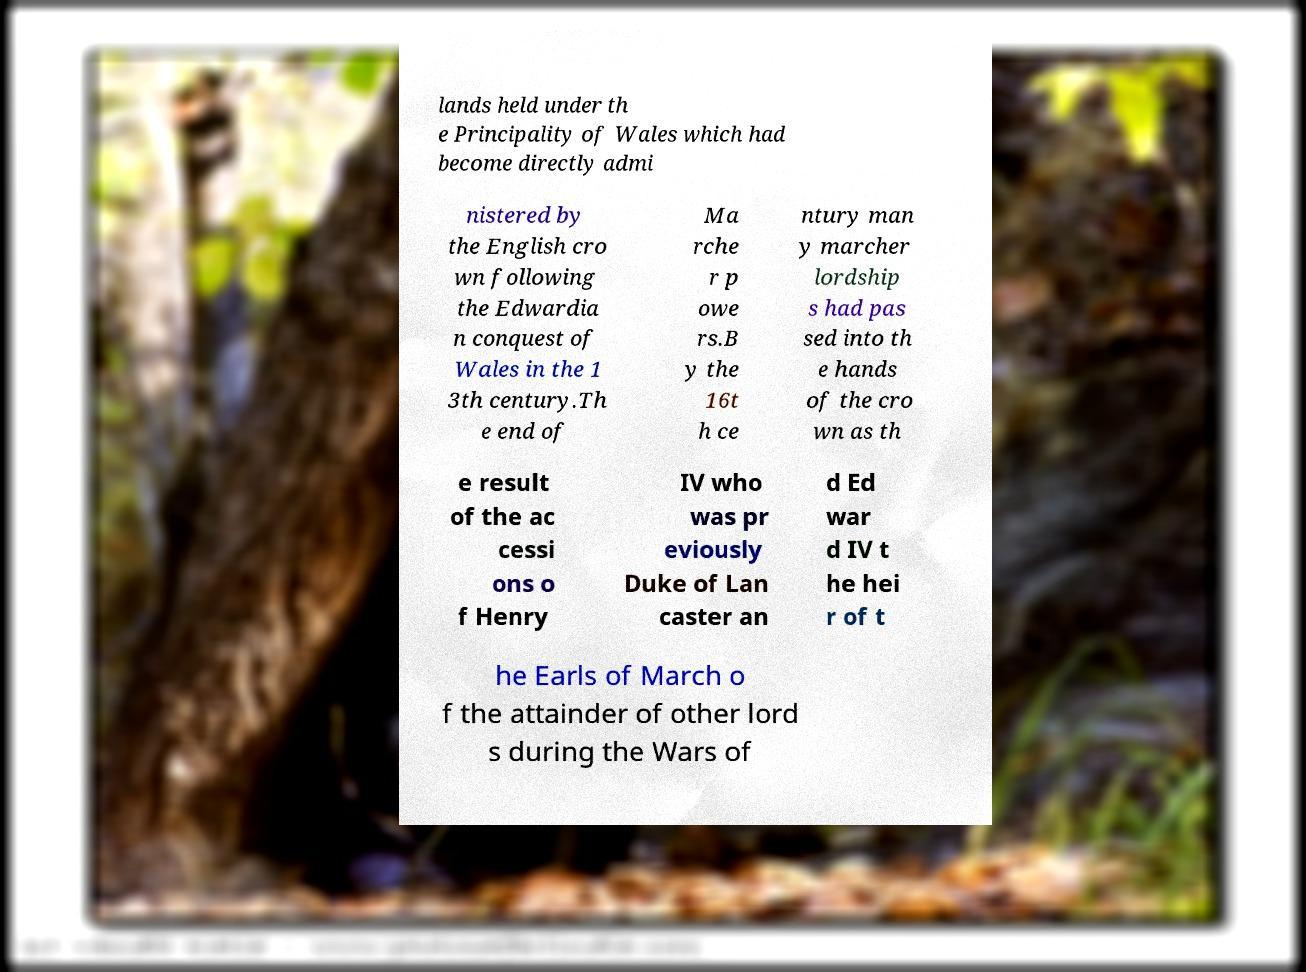There's text embedded in this image that I need extracted. Can you transcribe it verbatim? lands held under th e Principality of Wales which had become directly admi nistered by the English cro wn following the Edwardia n conquest of Wales in the 1 3th century.Th e end of Ma rche r p owe rs.B y the 16t h ce ntury man y marcher lordship s had pas sed into th e hands of the cro wn as th e result of the ac cessi ons o f Henry IV who was pr eviously Duke of Lan caster an d Ed war d IV t he hei r of t he Earls of March o f the attainder of other lord s during the Wars of 